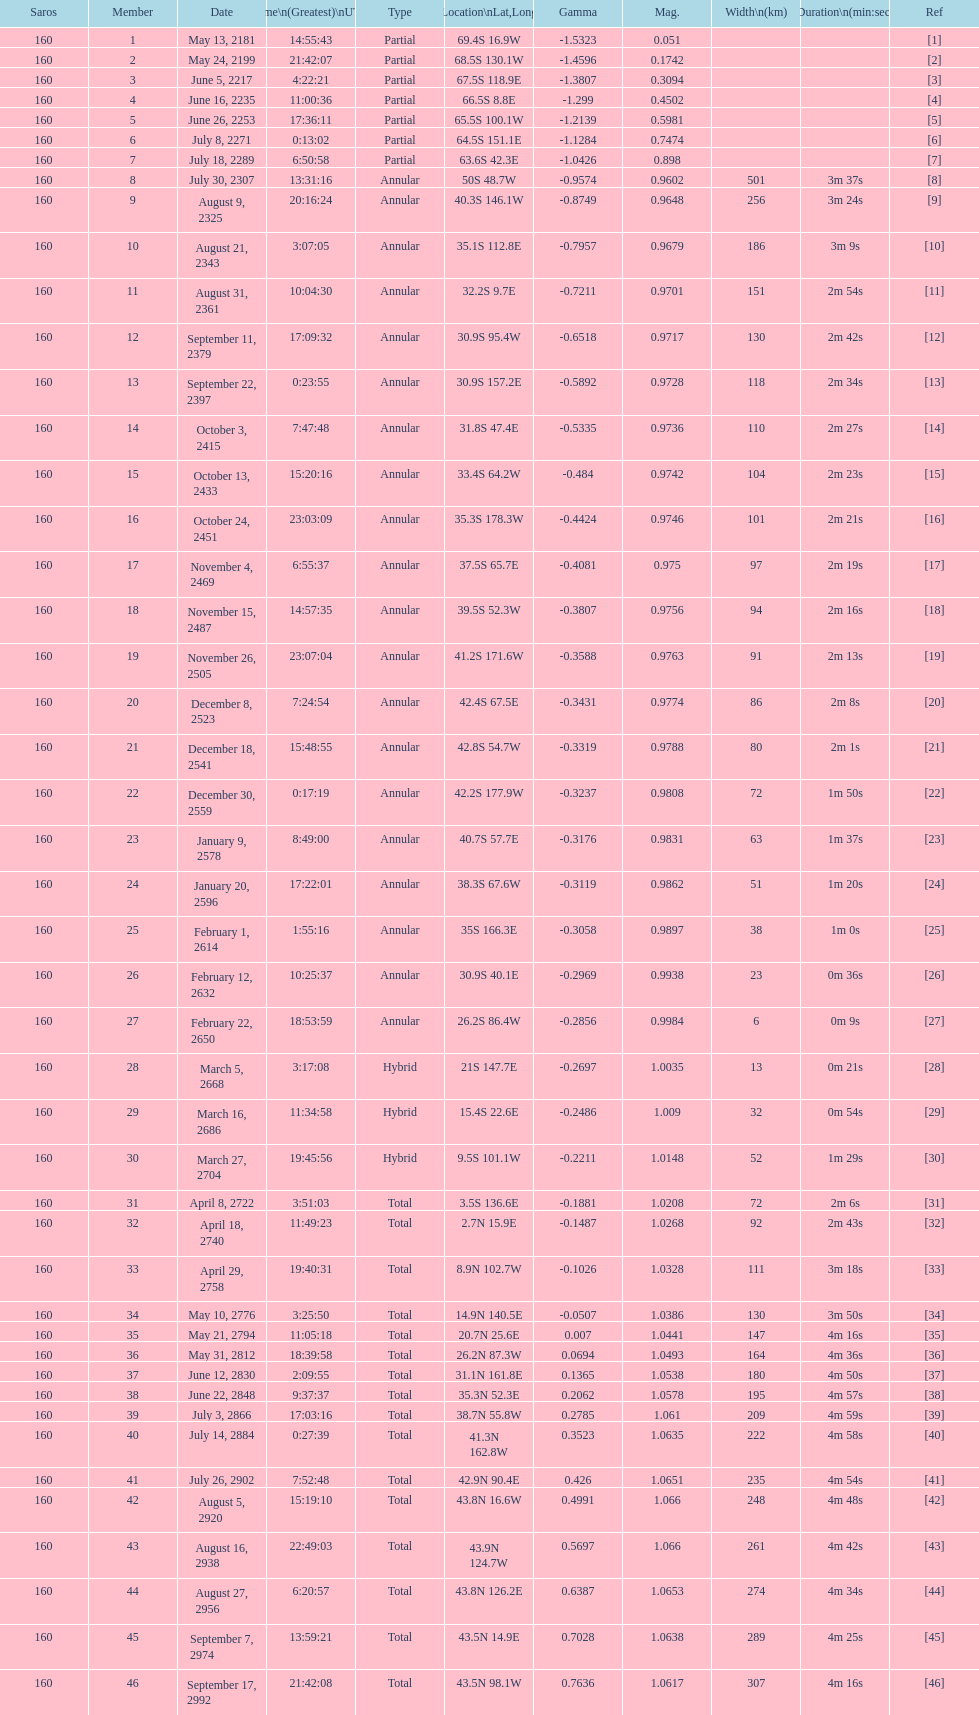When will the next solar saros be after the may 24, 2199 solar saros occurs? June 5, 2217. 